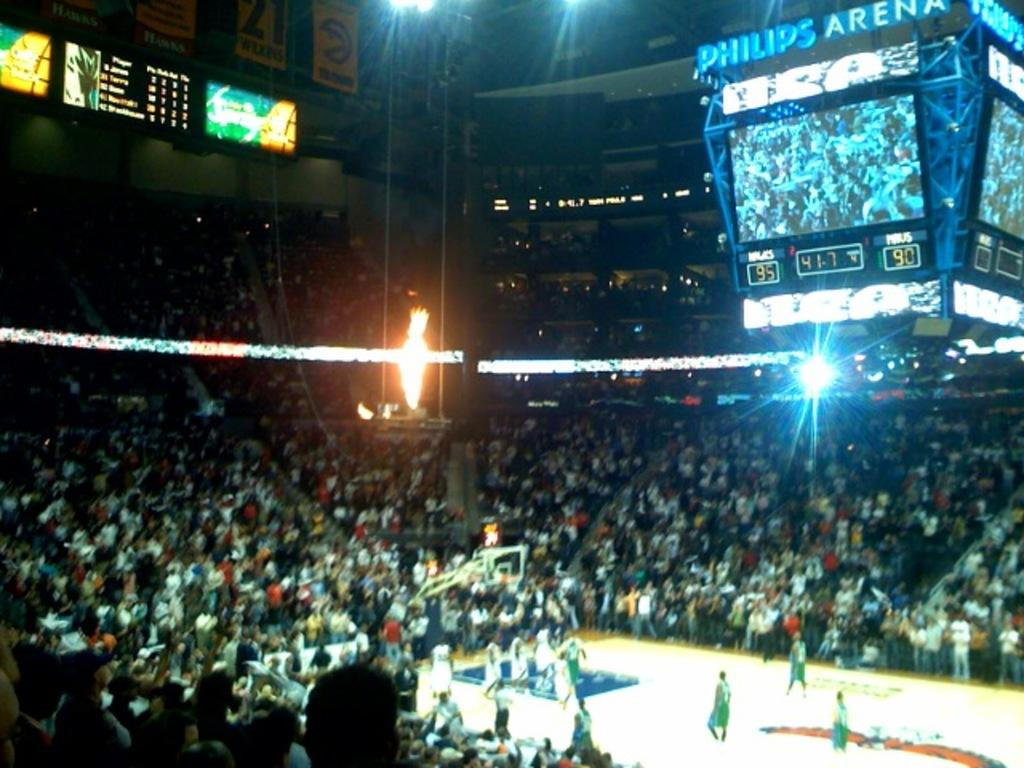<image>
Share a concise interpretation of the image provided. a sports game going on at the Philips Arena. 